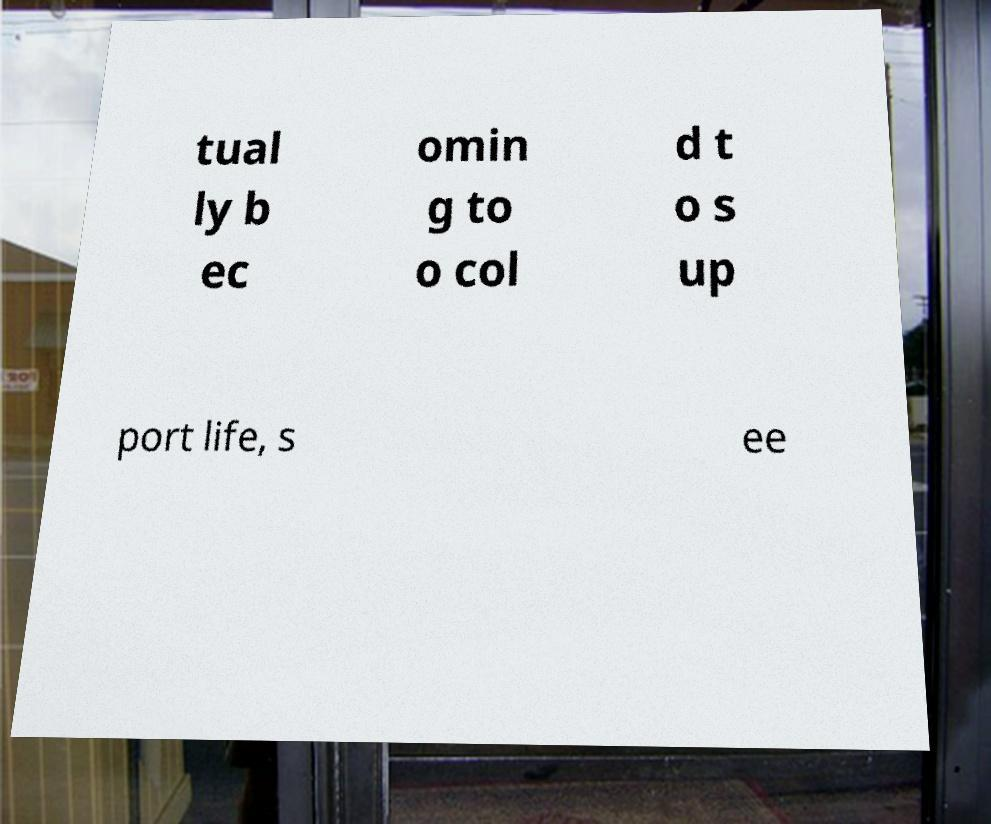I need the written content from this picture converted into text. Can you do that? tual ly b ec omin g to o col d t o s up port life, s ee 